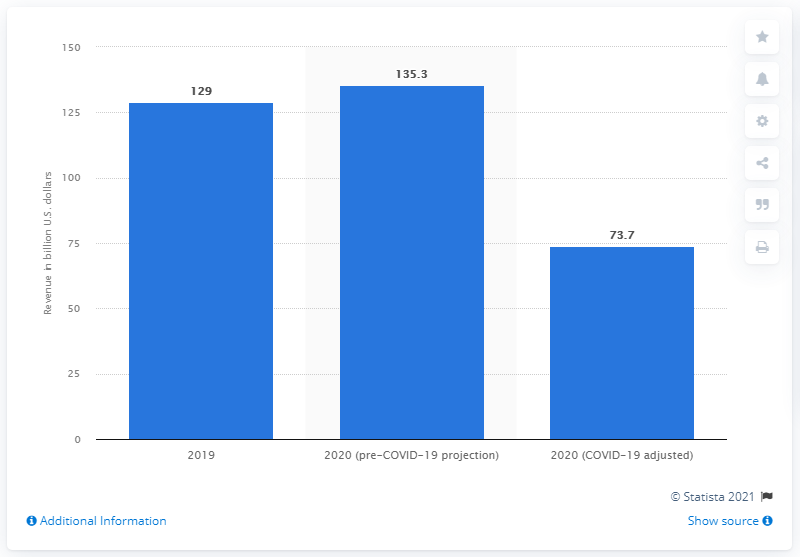Indicate a few pertinent items in this graphic. The estimated revenue in the sports industry for the year 2020 was approximately 73.7 billion U.S. dollars. 